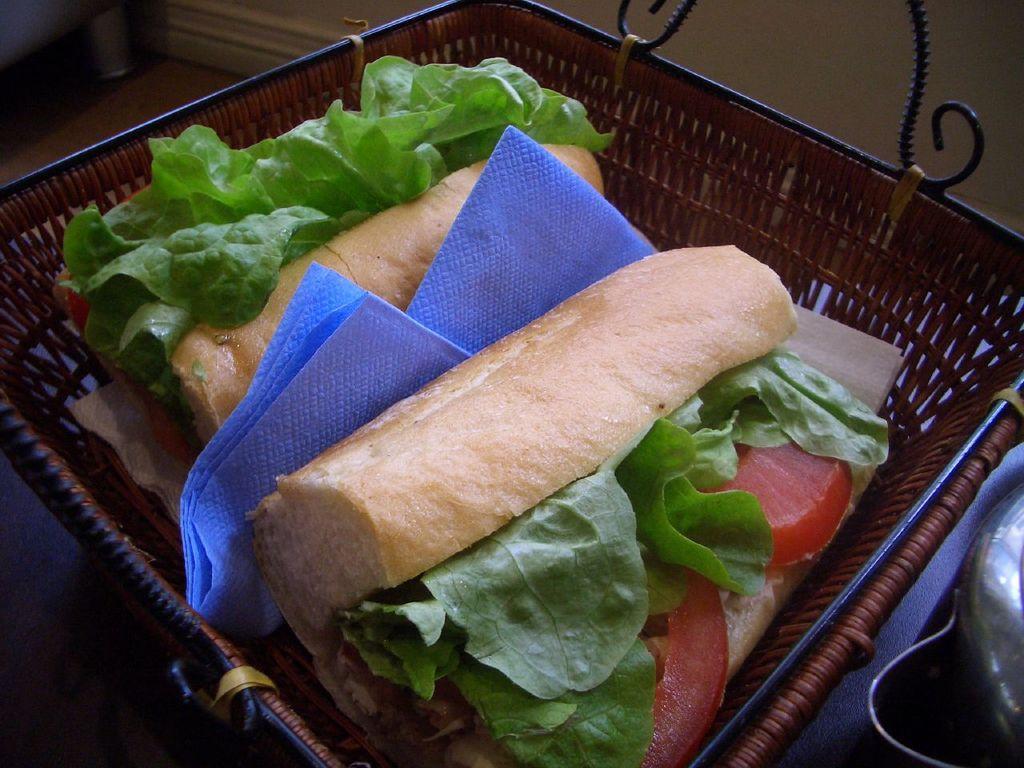How would you summarize this image in a sentence or two? In this picture, we see fast food and tissues are placed in the basket. In the background, we see a wall. In the right bottom of the picture, we see a steel vessel which looks like a water jug. 